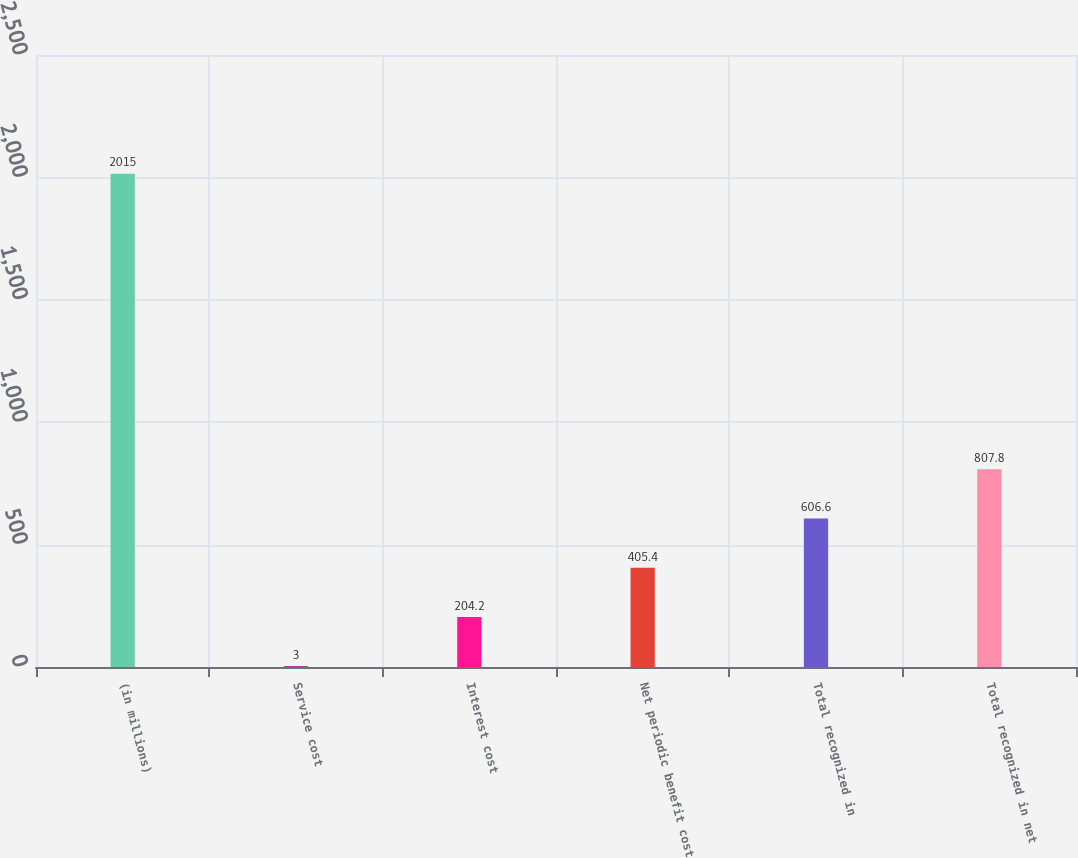Convert chart to OTSL. <chart><loc_0><loc_0><loc_500><loc_500><bar_chart><fcel>(in millions)<fcel>Service cost<fcel>Interest cost<fcel>Net periodic benefit cost<fcel>Total recognized in<fcel>Total recognized in net<nl><fcel>2015<fcel>3<fcel>204.2<fcel>405.4<fcel>606.6<fcel>807.8<nl></chart> 